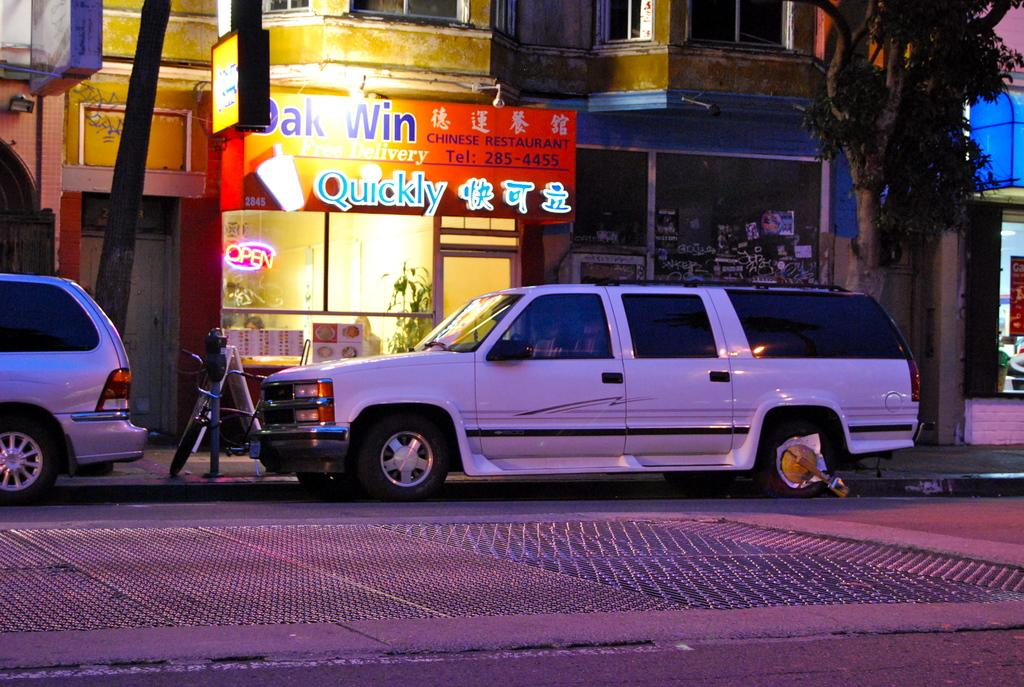What type of establishment is located in the middle of the image? There is a store in the middle of the image. What can be seen in the same area as the store? There are cars in the middle of the image. What mode of transportation is on the left side of the image? There is a cycle on the left side of the image. What type of plant is on the right side of the image? There is a tree on the right side of the image. What color are the trousers hanging on the tree in the image? There are no trousers present in the image; it features a store, cars, a cycle, and a tree. How many eggs can be seen on the cycle in the image? There are no eggs present in the image; it features a store, cars, a cycle, and a tree. 